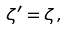Convert formula to latex. <formula><loc_0><loc_0><loc_500><loc_500>\zeta ^ { \prime } = \zeta \, ,</formula> 